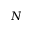<formula> <loc_0><loc_0><loc_500><loc_500>N</formula> 